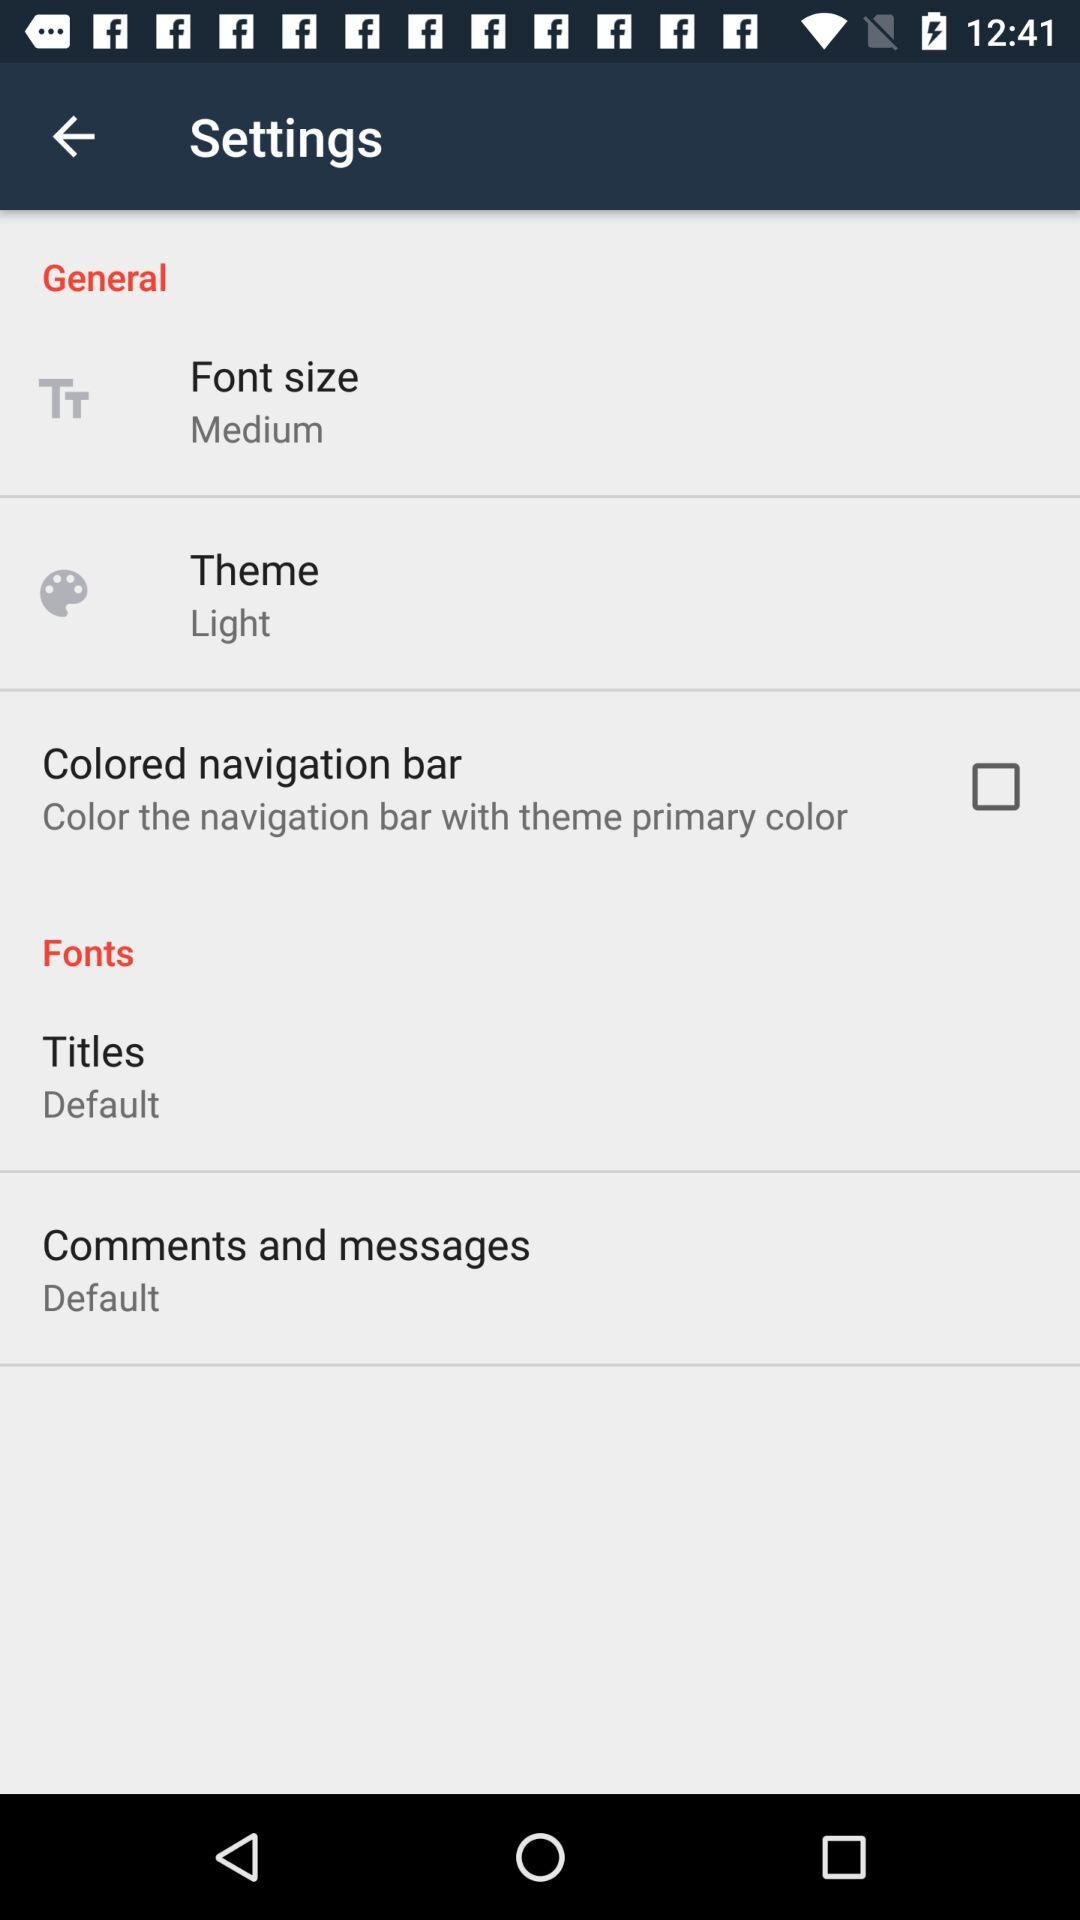What is the theme? The theme is "Light". 